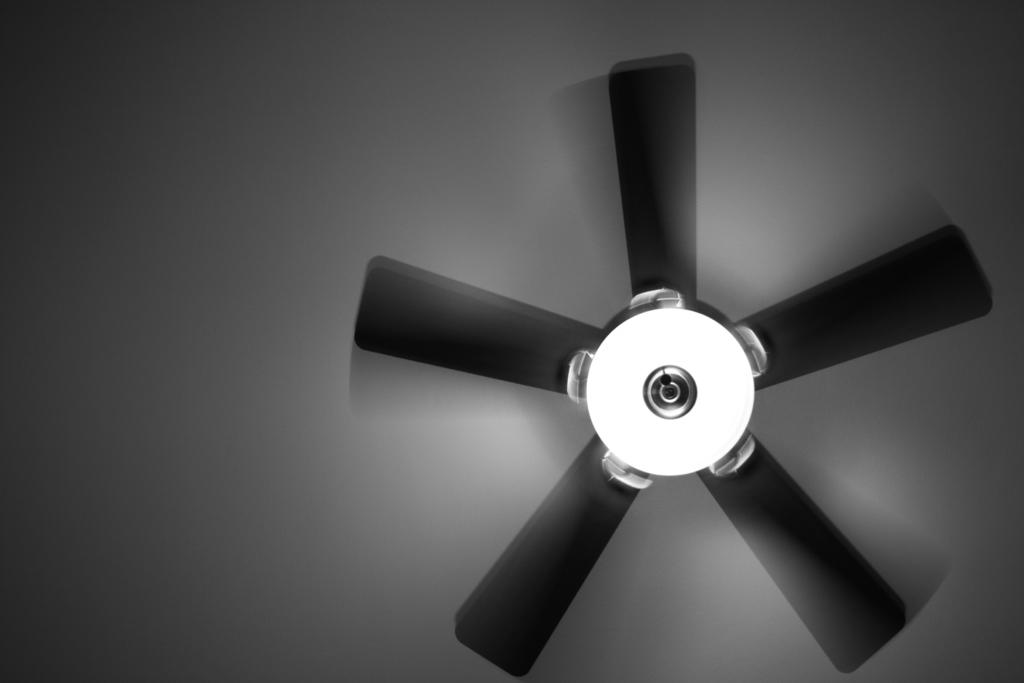What is the main object in the center of the image? There is a fan in the center of the image. What additional feature is attached to the fan? The fan has a light attached to it. Where are the fan and light located in the image? The fan and light are attached to the roof. How many jellyfish can be seen swimming near the fan in the image? There are no jellyfish present in the image; it features a fan and light attached to the roof. What type of crack is visible on the fan's blades in the image? There is no crack visible on the fan's blades in the image. 